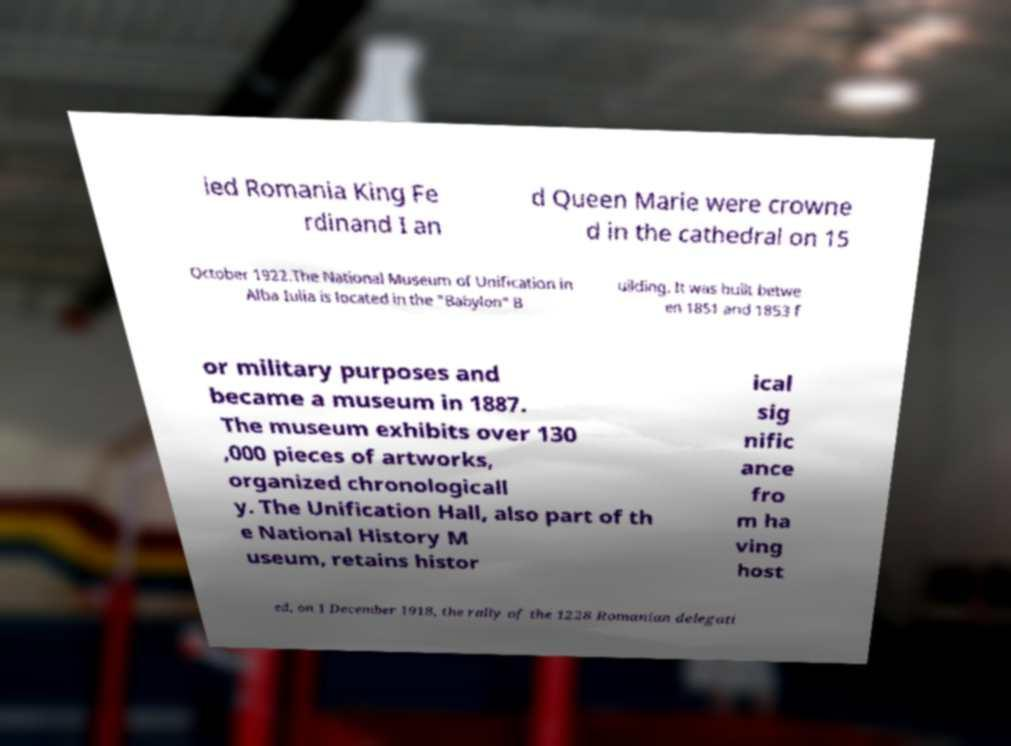What messages or text are displayed in this image? I need them in a readable, typed format. ied Romania King Fe rdinand I an d Queen Marie were crowne d in the cathedral on 15 October 1922.The National Museum of Unification in Alba Iulia is located in the "Babylon" B uilding. It was built betwe en 1851 and 1853 f or military purposes and became a museum in 1887. The museum exhibits over 130 ,000 pieces of artworks, organized chronologicall y. The Unification Hall, also part of th e National History M useum, retains histor ical sig nific ance fro m ha ving host ed, on 1 December 1918, the rally of the 1228 Romanian delegati 